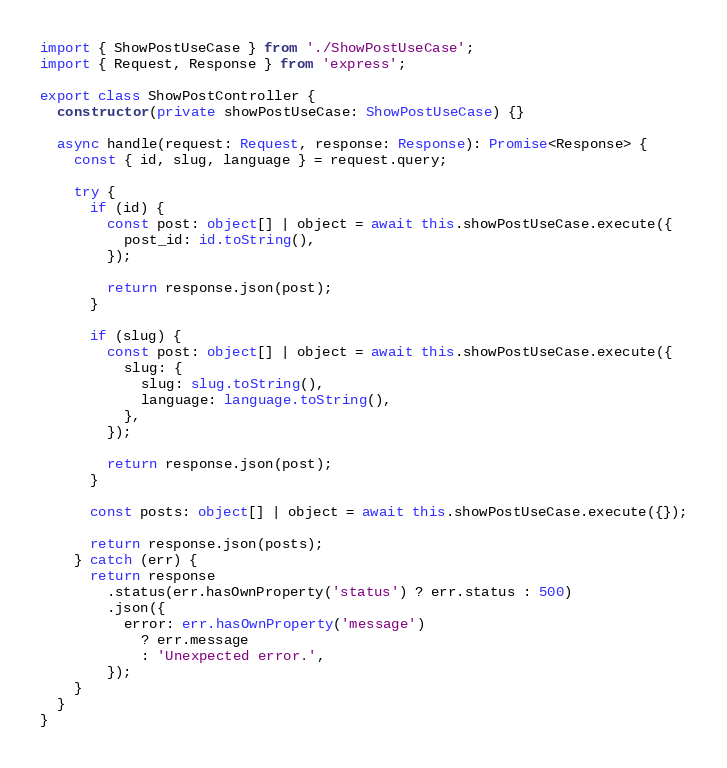Convert code to text. <code><loc_0><loc_0><loc_500><loc_500><_TypeScript_>import { ShowPostUseCase } from './ShowPostUseCase';
import { Request, Response } from 'express';

export class ShowPostController {
  constructor(private showPostUseCase: ShowPostUseCase) {}

  async handle(request: Request, response: Response): Promise<Response> {
    const { id, slug, language } = request.query;

    try {
      if (id) {
        const post: object[] | object = await this.showPostUseCase.execute({
          post_id: id.toString(),
        });

        return response.json(post);
      }

      if (slug) {
        const post: object[] | object = await this.showPostUseCase.execute({
          slug: {
            slug: slug.toString(),
            language: language.toString(),
          },
        });

        return response.json(post);
      }

      const posts: object[] | object = await this.showPostUseCase.execute({});

      return response.json(posts);
    } catch (err) {
      return response
        .status(err.hasOwnProperty('status') ? err.status : 500)
        .json({
          error: err.hasOwnProperty('message')
            ? err.message
            : 'Unexpected error.',
        });
    }
  }
}
</code> 